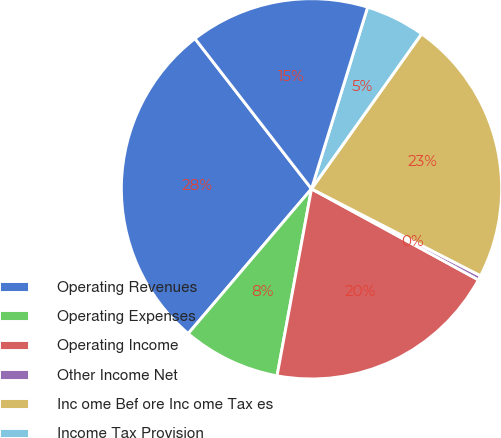<chart> <loc_0><loc_0><loc_500><loc_500><pie_chart><fcel>Operating Revenues<fcel>Operating Expenses<fcel>Operating Income<fcel>Other Income Net<fcel>Inc ome Bef ore Inc ome Tax es<fcel>Income Tax Provision<fcel>Net Income<nl><fcel>28.27%<fcel>8.33%<fcel>19.95%<fcel>0.39%<fcel>22.73%<fcel>5.06%<fcel>15.27%<nl></chart> 